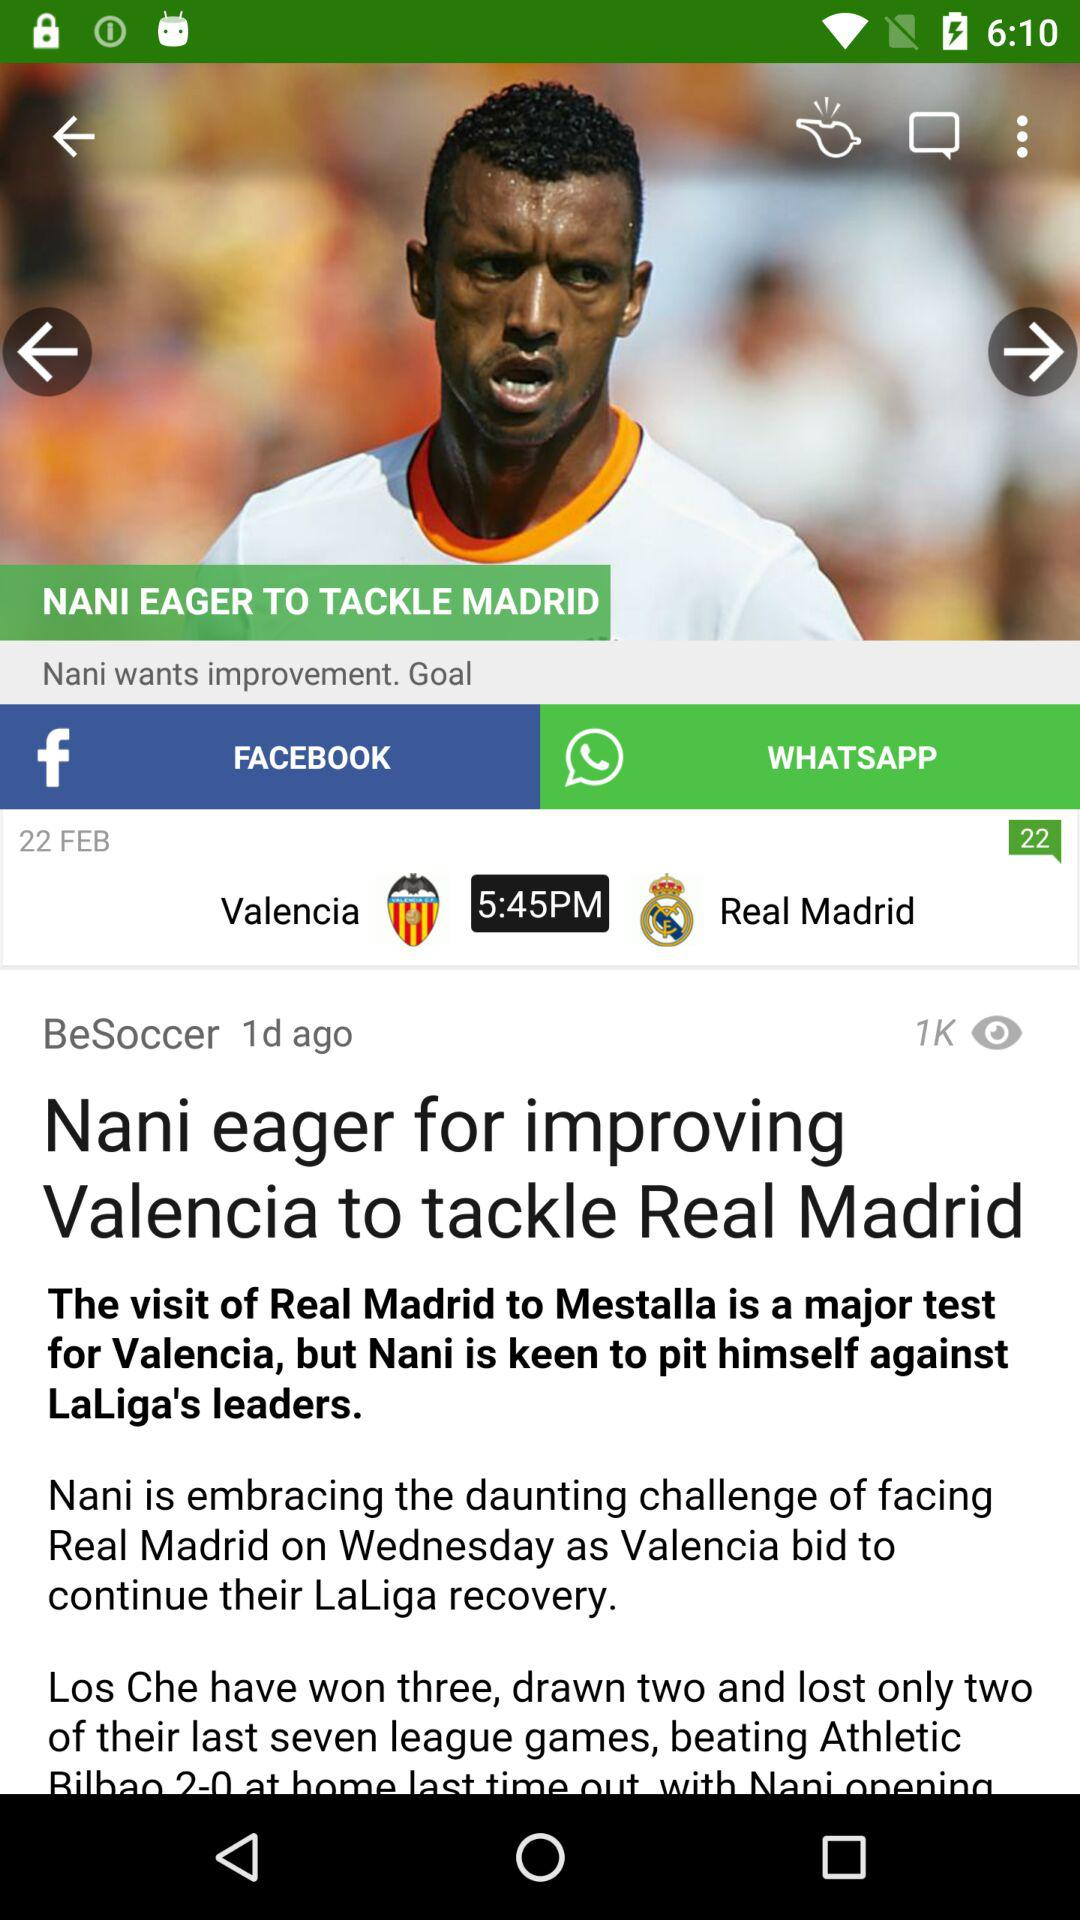How many more goals did Valencia score than Real Madrid in their last match?
Answer the question using a single word or phrase. 2 